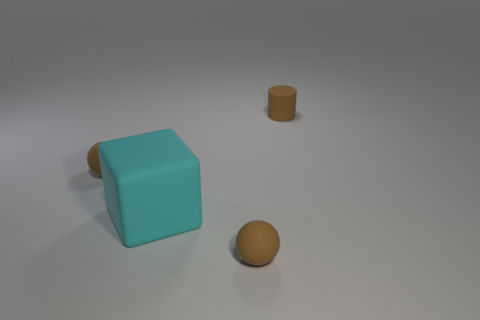Add 2 big cubes. How many objects exist? 6 Subtract all cubes. How many objects are left? 3 Add 1 cubes. How many cubes are left? 2 Add 3 large cyan cubes. How many large cyan cubes exist? 4 Subtract 0 cyan cylinders. How many objects are left? 4 Subtract all red cylinders. Subtract all yellow spheres. How many cylinders are left? 1 Subtract all purple rubber cylinders. Subtract all rubber things. How many objects are left? 0 